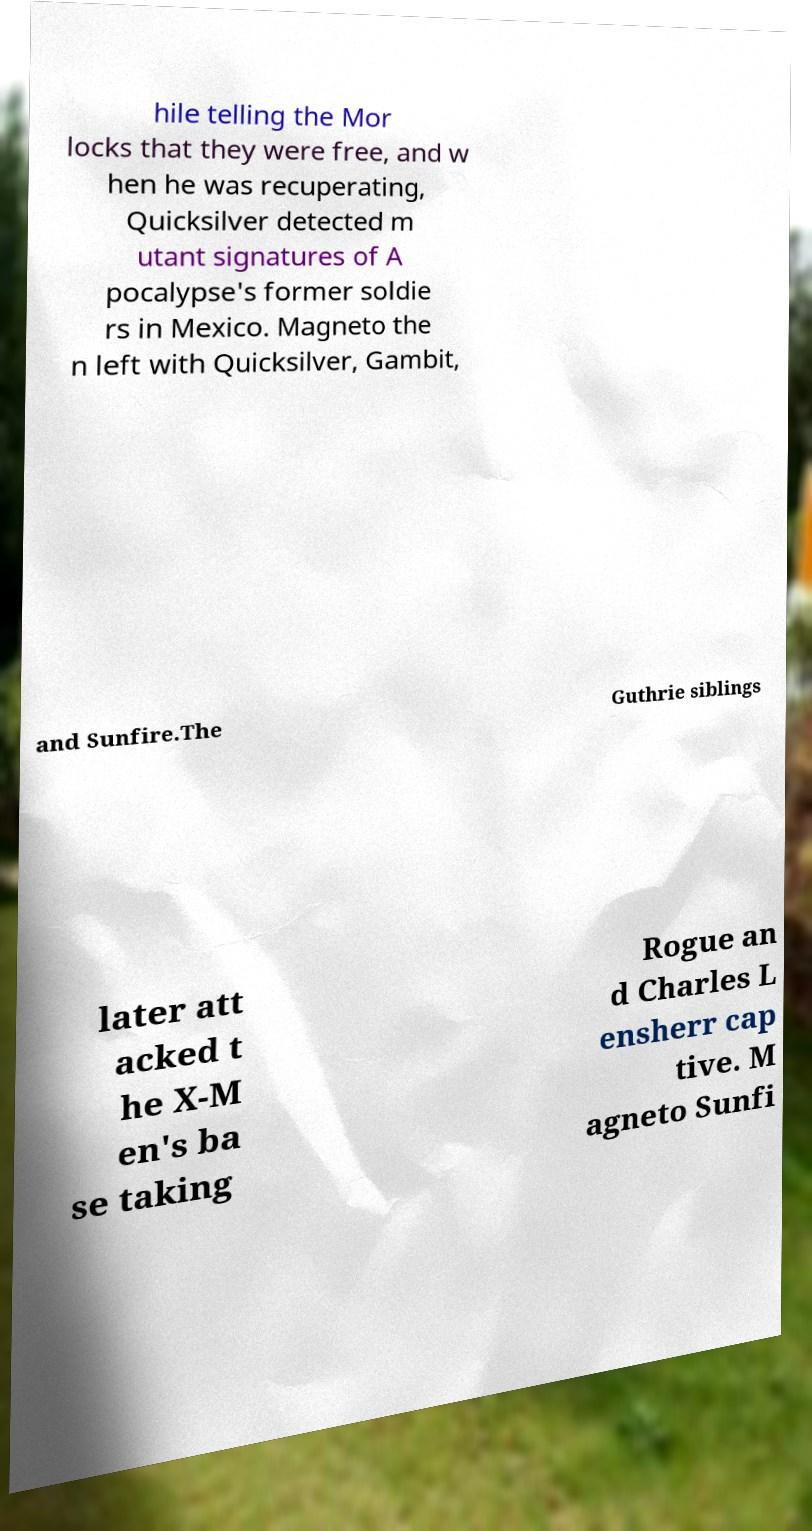I need the written content from this picture converted into text. Can you do that? hile telling the Mor locks that they were free, and w hen he was recuperating, Quicksilver detected m utant signatures of A pocalypse's former soldie rs in Mexico. Magneto the n left with Quicksilver, Gambit, and Sunfire.The Guthrie siblings later att acked t he X-M en's ba se taking Rogue an d Charles L ensherr cap tive. M agneto Sunfi 